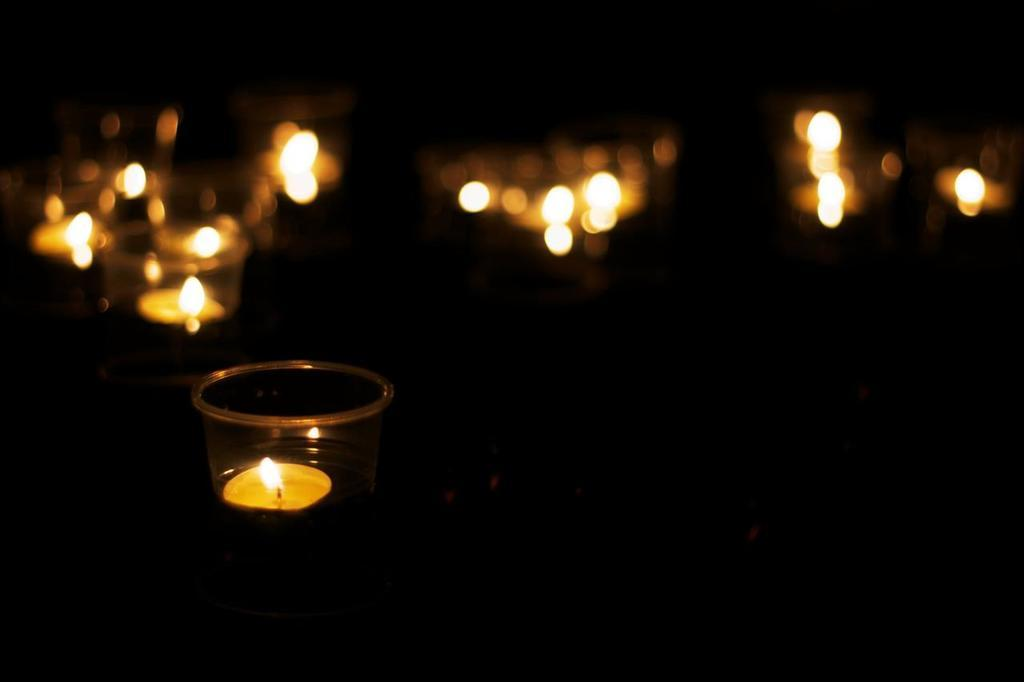What is the overall lighting condition in the image? The image is dark. What objects are present in the image that provide light? There are candles placed in bowls in the image. Can you describe the background of the image? The background is blurred. Can you see a snail moving across the stream in the image? There is no snail or stream present in the image. What type of blade is being used to cut the candles in the image? There is no blade visible in the image, and the candles are not being cut. 